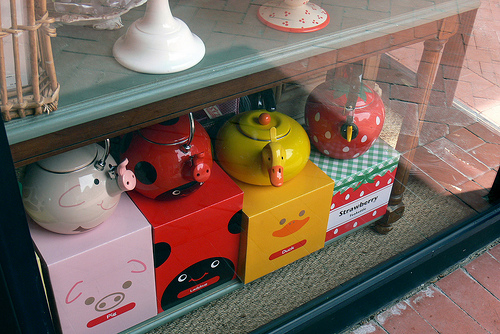<image>
Is the kettle behind the glass? Yes. From this viewpoint, the kettle is positioned behind the glass, with the glass partially or fully occluding the kettle. Where is the duck in relation to the duck? Is it under the duck? Yes. The duck is positioned underneath the duck, with the duck above it in the vertical space. 